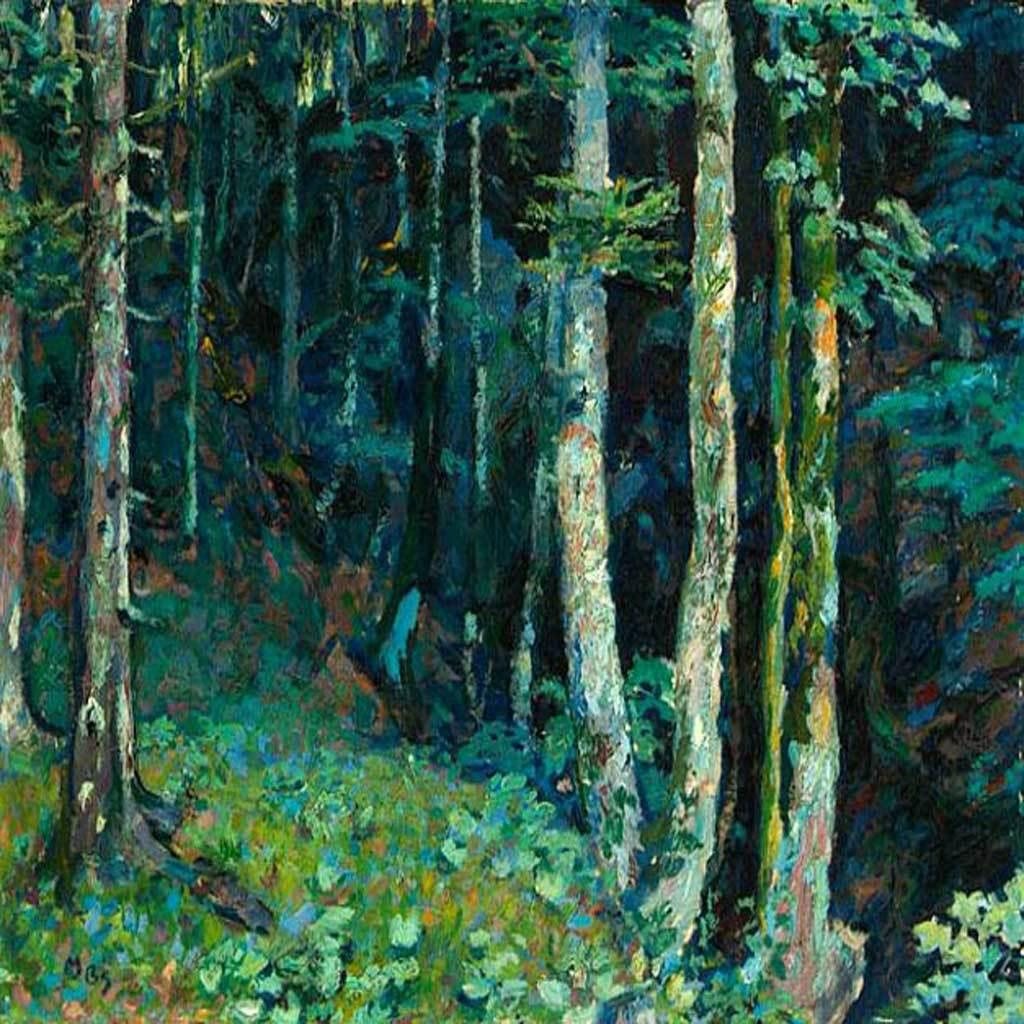What type of artwork is depicted in the image? The image is a painting. What natural elements can be seen in the painting? There are plants and trees in the image. Reasoning: Leting: Let's think step by step in order to produce the conversation about the painting. We start by identifying the medium of the artwork, which is a painting. Then, we focus on the content of the painting, mentioning the presence of plants and trees. Each question is designed to elicit a specific detail about the image that is known from the provided facts. Absurd Question/Answer: What type of question is being asked in the painting? There is no question present in the painting; it is a visual representation of plants and trees. Is there a van parked near the trees in the painting? There is no van present in the painting; it only features plants and trees. 